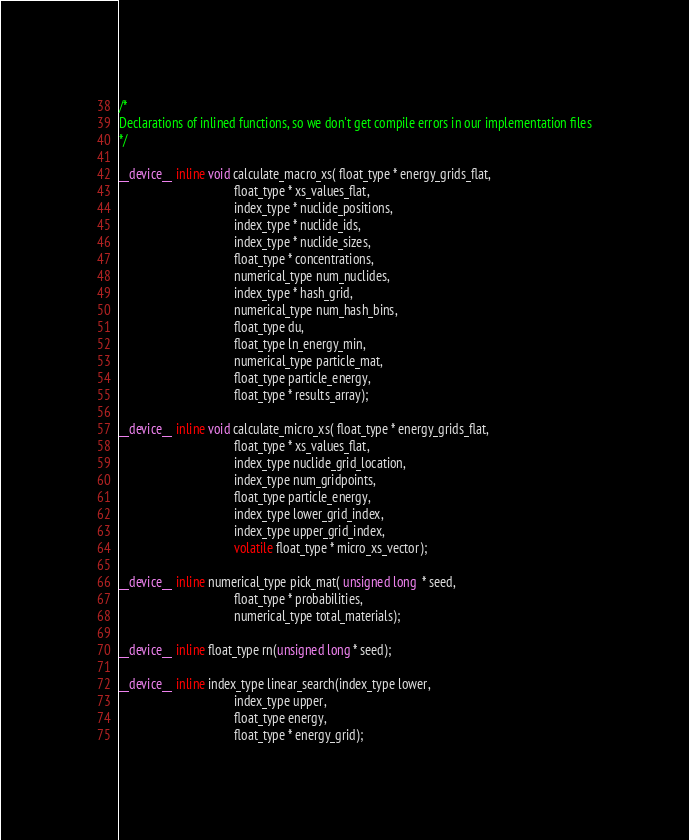Convert code to text. <code><loc_0><loc_0><loc_500><loc_500><_Cuda_>/*
Declarations of inlined functions, so we don't get compile errors in our implementation files
*/

__device__ inline void calculate_macro_xs( float_type * energy_grids_flat,
									float_type * xs_values_flat,
									index_type * nuclide_positions,
									index_type * nuclide_ids,
									index_type * nuclide_sizes,
									float_type * concentrations,
									numerical_type num_nuclides,
									index_type * hash_grid,
									numerical_type num_hash_bins,
									float_type du,
									float_type ln_energy_min,
									numerical_type particle_mat,
									float_type particle_energy,
									float_type * results_array);

__device__ inline void calculate_micro_xs( float_type * energy_grids_flat,
									float_type * xs_values_flat,
									index_type nuclide_grid_location,
									index_type num_gridpoints,
									float_type particle_energy,
									index_type lower_grid_index,
									index_type upper_grid_index,
									volatile float_type * micro_xs_vector);

__device__ inline numerical_type pick_mat( unsigned long  * seed,
									float_type * probabilities,
									numerical_type total_materials);

__device__ inline float_type rn(unsigned long * seed);

__device__ inline index_type linear_search(index_type lower,
									index_type upper,
									float_type energy,
									float_type * energy_grid);
</code> 